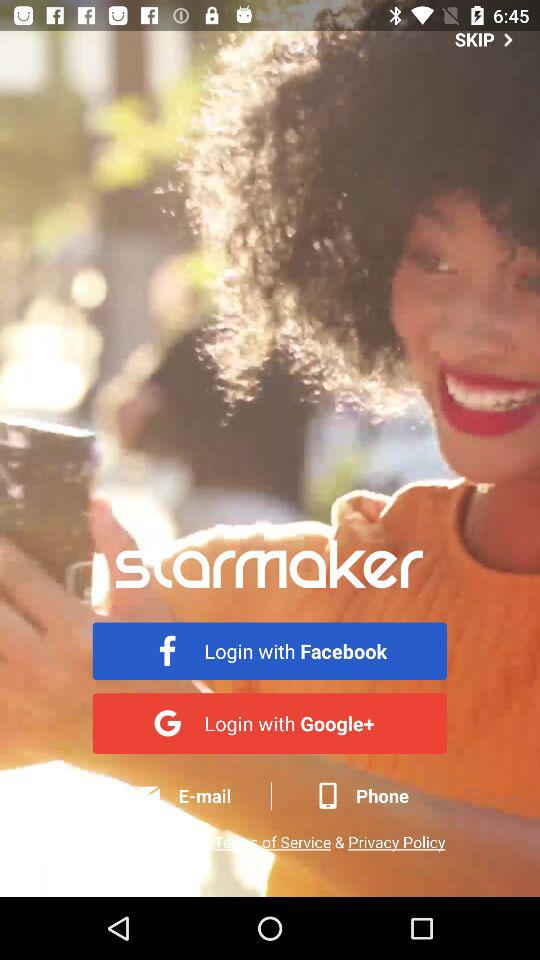What accounts can I use to sign up?
When the provided information is insufficient, respond with <no answer>. <no answer> 